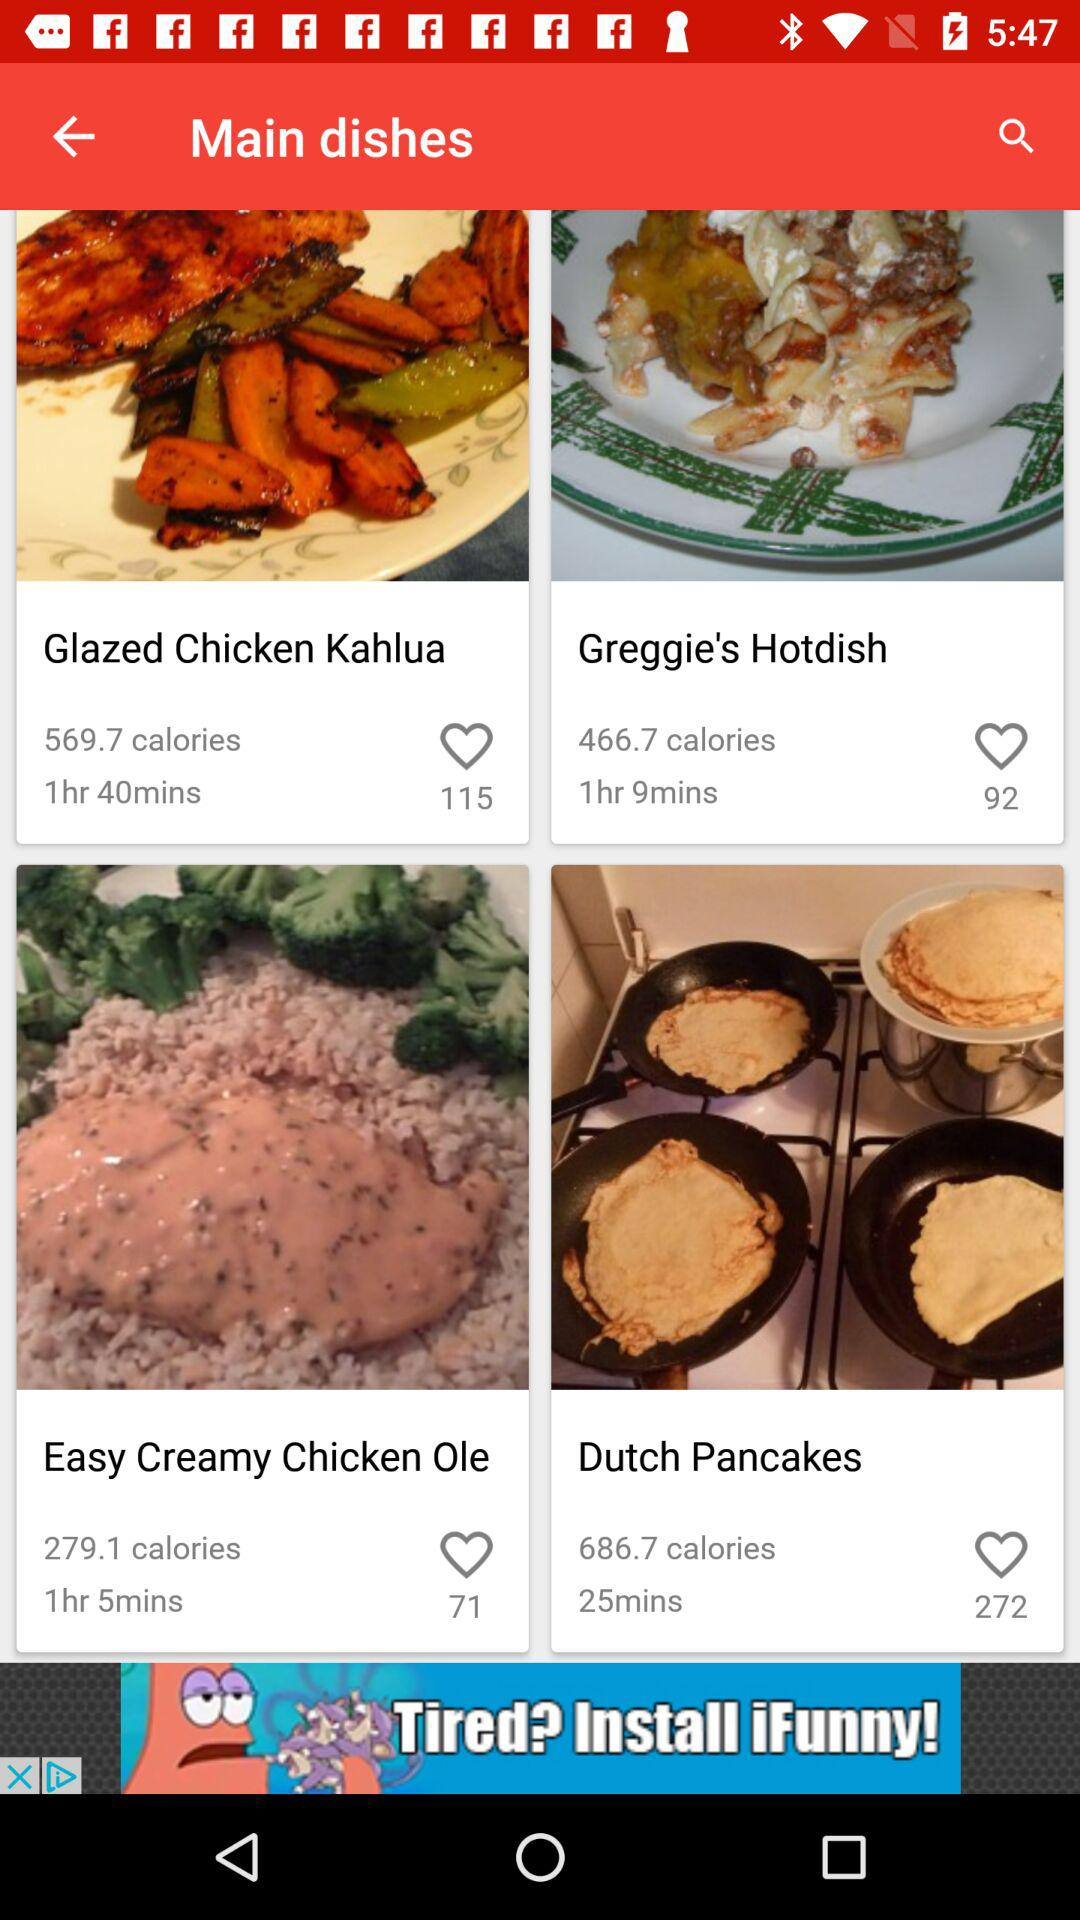How long is the preparation time for the Dutch pancakes?
When the provided information is insufficient, respond with <no answer>. <no answer> 